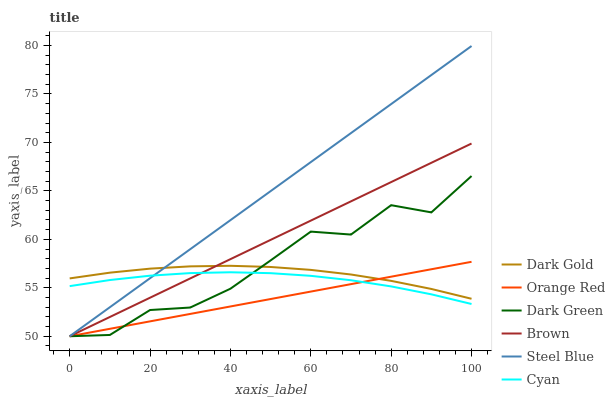Does Orange Red have the minimum area under the curve?
Answer yes or no. Yes. Does Steel Blue have the maximum area under the curve?
Answer yes or no. Yes. Does Dark Gold have the minimum area under the curve?
Answer yes or no. No. Does Dark Gold have the maximum area under the curve?
Answer yes or no. No. Is Orange Red the smoothest?
Answer yes or no. Yes. Is Dark Green the roughest?
Answer yes or no. Yes. Is Dark Gold the smoothest?
Answer yes or no. No. Is Dark Gold the roughest?
Answer yes or no. No. Does Brown have the lowest value?
Answer yes or no. Yes. Does Dark Gold have the lowest value?
Answer yes or no. No. Does Steel Blue have the highest value?
Answer yes or no. Yes. Does Dark Gold have the highest value?
Answer yes or no. No. Is Cyan less than Dark Gold?
Answer yes or no. Yes. Is Dark Gold greater than Cyan?
Answer yes or no. Yes. Does Dark Green intersect Dark Gold?
Answer yes or no. Yes. Is Dark Green less than Dark Gold?
Answer yes or no. No. Is Dark Green greater than Dark Gold?
Answer yes or no. No. Does Cyan intersect Dark Gold?
Answer yes or no. No. 